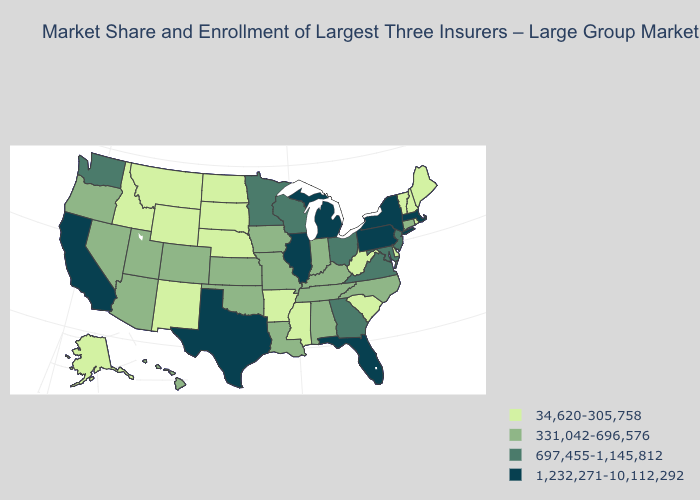Does Texas have the highest value in the South?
Quick response, please. Yes. Does the map have missing data?
Answer briefly. No. Does Kentucky have the same value as Rhode Island?
Short answer required. No. Among the states that border Virginia , which have the highest value?
Be succinct. Maryland. Name the states that have a value in the range 331,042-696,576?
Write a very short answer. Alabama, Arizona, Colorado, Connecticut, Hawaii, Indiana, Iowa, Kansas, Kentucky, Louisiana, Missouri, Nevada, North Carolina, Oklahoma, Oregon, Tennessee, Utah. What is the value of Texas?
Answer briefly. 1,232,271-10,112,292. Name the states that have a value in the range 1,232,271-10,112,292?
Quick response, please. California, Florida, Illinois, Massachusetts, Michigan, New York, Pennsylvania, Texas. Name the states that have a value in the range 697,455-1,145,812?
Concise answer only. Georgia, Maryland, Minnesota, New Jersey, Ohio, Virginia, Washington, Wisconsin. Name the states that have a value in the range 697,455-1,145,812?
Short answer required. Georgia, Maryland, Minnesota, New Jersey, Ohio, Virginia, Washington, Wisconsin. Among the states that border West Virginia , does Kentucky have the lowest value?
Write a very short answer. Yes. Among the states that border Idaho , which have the lowest value?
Write a very short answer. Montana, Wyoming. Does Florida have the same value as Pennsylvania?
Concise answer only. Yes. Name the states that have a value in the range 331,042-696,576?
Short answer required. Alabama, Arizona, Colorado, Connecticut, Hawaii, Indiana, Iowa, Kansas, Kentucky, Louisiana, Missouri, Nevada, North Carolina, Oklahoma, Oregon, Tennessee, Utah. Which states have the lowest value in the USA?
Quick response, please. Alaska, Arkansas, Delaware, Idaho, Maine, Mississippi, Montana, Nebraska, New Hampshire, New Mexico, North Dakota, Rhode Island, South Carolina, South Dakota, Vermont, West Virginia, Wyoming. 